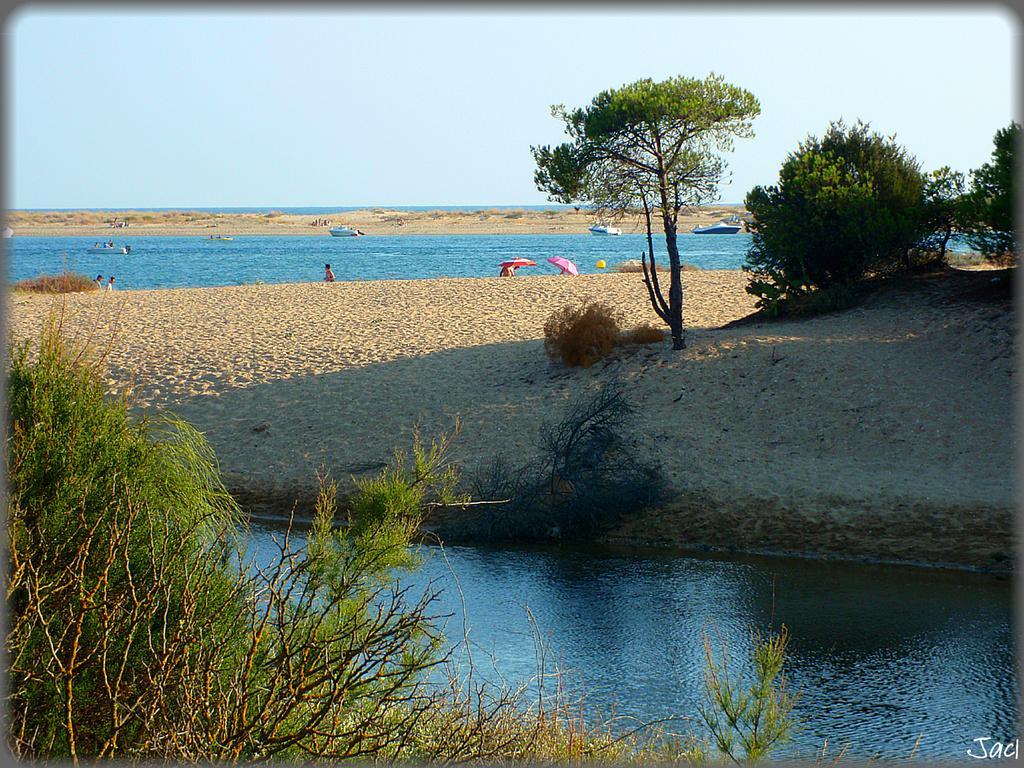How would you summarize this image in a sentence or two? In this image we can see the trees, plants and also the grass. We can also see the sand, water, boats and some people and also two umbrellas. Sky is also visible. In the bottom right corner we can see the text and the image has borders. 